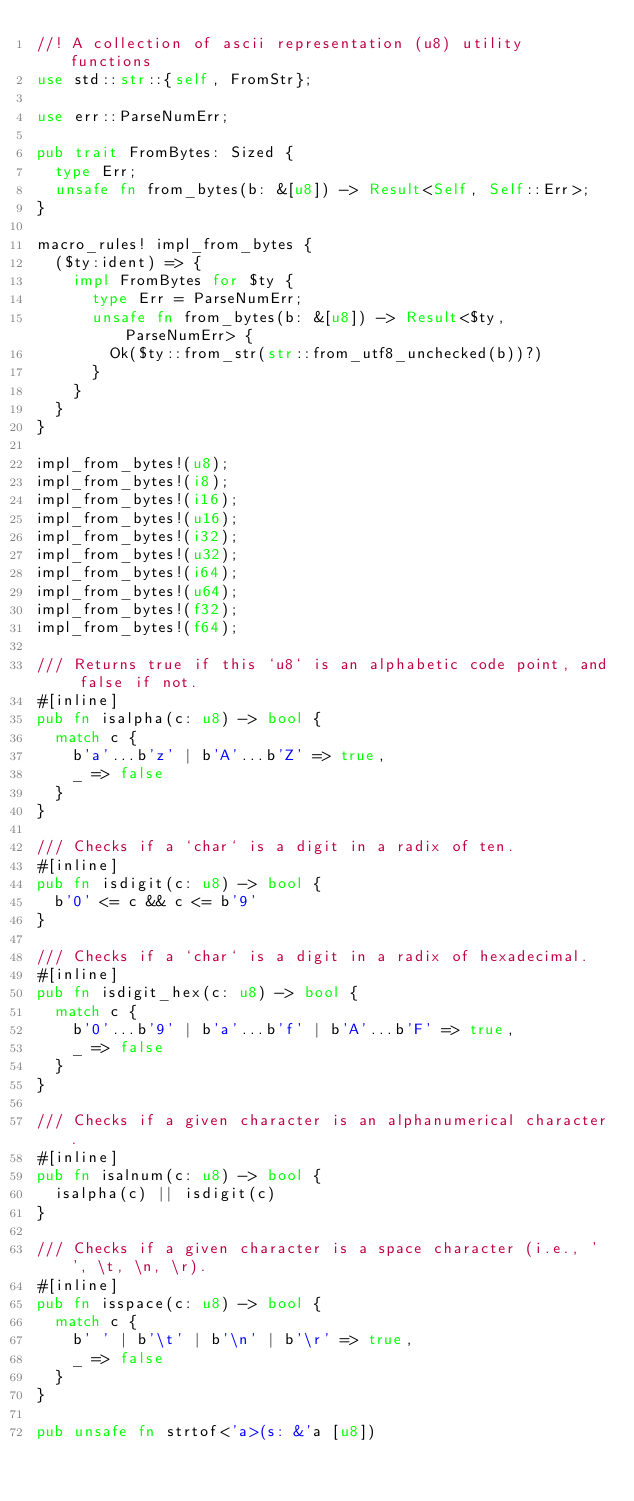Convert code to text. <code><loc_0><loc_0><loc_500><loc_500><_Rust_>//! A collection of ascii representation (u8) utility functions
use std::str::{self, FromStr};

use err::ParseNumErr;

pub trait FromBytes: Sized {
  type Err;
  unsafe fn from_bytes(b: &[u8]) -> Result<Self, Self::Err>;
}

macro_rules! impl_from_bytes {
  ($ty:ident) => {
    impl FromBytes for $ty {
      type Err = ParseNumErr;
      unsafe fn from_bytes(b: &[u8]) -> Result<$ty, ParseNumErr> {
        Ok($ty::from_str(str::from_utf8_unchecked(b))?)
      }
    }
  }
}

impl_from_bytes!(u8);
impl_from_bytes!(i8);
impl_from_bytes!(i16);
impl_from_bytes!(u16);
impl_from_bytes!(i32);
impl_from_bytes!(u32);
impl_from_bytes!(i64);
impl_from_bytes!(u64);
impl_from_bytes!(f32);
impl_from_bytes!(f64);

/// Returns true if this `u8` is an alphabetic code point, and false if not.
#[inline]
pub fn isalpha(c: u8) -> bool {
  match c {
    b'a'...b'z' | b'A'...b'Z' => true,
    _ => false
  }
}

/// Checks if a `char` is a digit in a radix of ten.
#[inline]
pub fn isdigit(c: u8) -> bool {
  b'0' <= c && c <= b'9'
}

/// Checks if a `char` is a digit in a radix of hexadecimal.
#[inline]
pub fn isdigit_hex(c: u8) -> bool {
  match c {
    b'0'...b'9' | b'a'...b'f' | b'A'...b'F' => true,
    _ => false
  }
}

/// Checks if a given character is an alphanumerical character.
#[inline]
pub fn isalnum(c: u8) -> bool {
  isalpha(c) || isdigit(c)
}

/// Checks if a given character is a space character (i.e., ' ', \t, \n, \r).
#[inline]
pub fn isspace(c: u8) -> bool {
  match c {
    b' ' | b'\t' | b'\n' | b'\r' => true,
    _ => false
  }
}

pub unsafe fn strtof<'a>(s: &'a [u8])</code> 